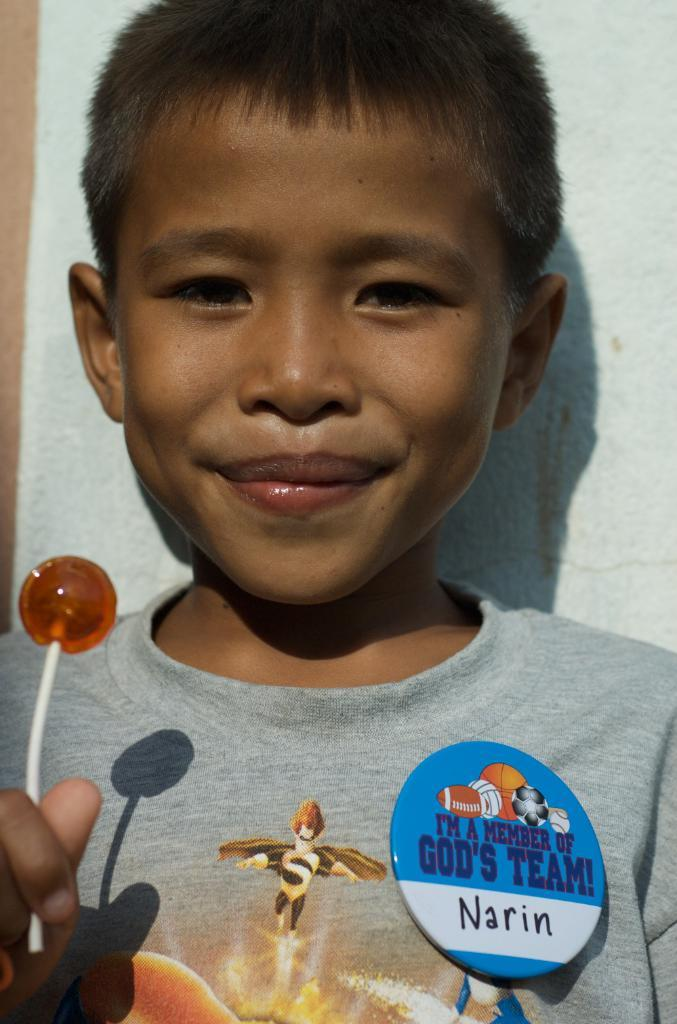Who is in the image? There is a boy in the image. What is the boy doing in the image? The boy is smiling in the image. What is the boy holding in the image? The boy is holding a lollipop in the image. What can be seen in the background of the image? There is a wall in the background of the image. What time of day is it in the image, based on the hour shown on a clock? There is no clock visible in the image, so we cannot determine the time of day based on an hour. 